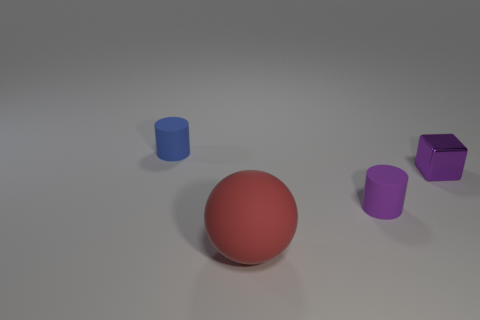Add 4 purple matte objects. How many objects exist? 8 Subtract all blue cylinders. How many cylinders are left? 1 Subtract 1 cylinders. How many cylinders are left? 1 Add 4 tiny matte cylinders. How many tiny matte cylinders exist? 6 Subtract 0 cyan balls. How many objects are left? 4 Subtract all blocks. How many objects are left? 3 Subtract all green cylinders. Subtract all brown blocks. How many cylinders are left? 2 Subtract all purple blocks. How many gray balls are left? 0 Subtract all small metallic blocks. Subtract all small blue rubber cylinders. How many objects are left? 2 Add 4 small purple cylinders. How many small purple cylinders are left? 5 